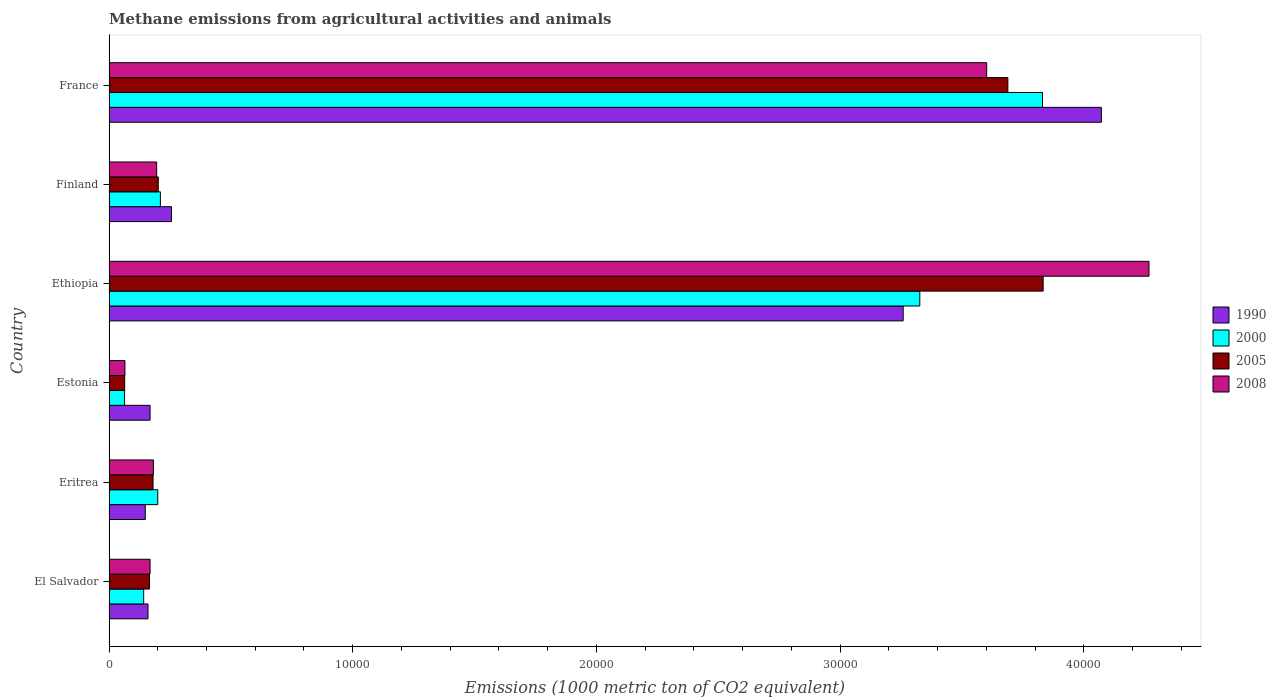How many different coloured bars are there?
Provide a short and direct response. 4. Are the number of bars per tick equal to the number of legend labels?
Make the answer very short. Yes. Are the number of bars on each tick of the Y-axis equal?
Offer a very short reply. Yes. What is the label of the 3rd group of bars from the top?
Offer a very short reply. Ethiopia. In how many cases, is the number of bars for a given country not equal to the number of legend labels?
Offer a terse response. 0. What is the amount of methane emitted in 2005 in France?
Your answer should be very brief. 3.69e+04. Across all countries, what is the maximum amount of methane emitted in 1990?
Make the answer very short. 4.07e+04. Across all countries, what is the minimum amount of methane emitted in 2005?
Your answer should be very brief. 642.9. In which country was the amount of methane emitted in 2005 maximum?
Your answer should be very brief. Ethiopia. In which country was the amount of methane emitted in 2008 minimum?
Offer a terse response. Estonia. What is the total amount of methane emitted in 1990 in the graph?
Your answer should be very brief. 8.06e+04. What is the difference between the amount of methane emitted in 1990 in Estonia and that in France?
Provide a succinct answer. -3.90e+04. What is the difference between the amount of methane emitted in 2000 in France and the amount of methane emitted in 1990 in Ethiopia?
Your answer should be very brief. 5716.5. What is the average amount of methane emitted in 2000 per country?
Offer a terse response. 1.30e+04. What is the difference between the amount of methane emitted in 2005 and amount of methane emitted in 2008 in Finland?
Offer a terse response. 65.1. What is the ratio of the amount of methane emitted in 2005 in Ethiopia to that in France?
Provide a succinct answer. 1.04. Is the amount of methane emitted in 2005 in Estonia less than that in France?
Provide a succinct answer. Yes. What is the difference between the highest and the second highest amount of methane emitted in 2008?
Offer a terse response. 6659. What is the difference between the highest and the lowest amount of methane emitted in 2005?
Offer a very short reply. 3.77e+04. Is the sum of the amount of methane emitted in 2000 in Eritrea and Finland greater than the maximum amount of methane emitted in 1990 across all countries?
Make the answer very short. No. What does the 1st bar from the top in El Salvador represents?
Provide a short and direct response. 2008. Is it the case that in every country, the sum of the amount of methane emitted in 2000 and amount of methane emitted in 2005 is greater than the amount of methane emitted in 1990?
Your answer should be compact. No. Are all the bars in the graph horizontal?
Offer a very short reply. Yes. How many countries are there in the graph?
Make the answer very short. 6. Are the values on the major ticks of X-axis written in scientific E-notation?
Offer a terse response. No. Does the graph contain grids?
Give a very brief answer. No. Where does the legend appear in the graph?
Your response must be concise. Center right. How many legend labels are there?
Offer a very short reply. 4. What is the title of the graph?
Provide a short and direct response. Methane emissions from agricultural activities and animals. Does "1978" appear as one of the legend labels in the graph?
Make the answer very short. No. What is the label or title of the X-axis?
Offer a terse response. Emissions (1000 metric ton of CO2 equivalent). What is the label or title of the Y-axis?
Offer a terse response. Country. What is the Emissions (1000 metric ton of CO2 equivalent) in 1990 in El Salvador?
Your answer should be compact. 1599.5. What is the Emissions (1000 metric ton of CO2 equivalent) in 2000 in El Salvador?
Provide a short and direct response. 1421.9. What is the Emissions (1000 metric ton of CO2 equivalent) of 2005 in El Salvador?
Ensure brevity in your answer.  1662.1. What is the Emissions (1000 metric ton of CO2 equivalent) of 2008 in El Salvador?
Keep it short and to the point. 1684.6. What is the Emissions (1000 metric ton of CO2 equivalent) of 1990 in Eritrea?
Offer a very short reply. 1488.1. What is the Emissions (1000 metric ton of CO2 equivalent) in 2000 in Eritrea?
Provide a short and direct response. 2000.3. What is the Emissions (1000 metric ton of CO2 equivalent) of 2005 in Eritrea?
Make the answer very short. 1806.6. What is the Emissions (1000 metric ton of CO2 equivalent) in 2008 in Eritrea?
Offer a very short reply. 1820.8. What is the Emissions (1000 metric ton of CO2 equivalent) in 1990 in Estonia?
Give a very brief answer. 1685. What is the Emissions (1000 metric ton of CO2 equivalent) in 2000 in Estonia?
Provide a succinct answer. 637.9. What is the Emissions (1000 metric ton of CO2 equivalent) of 2005 in Estonia?
Ensure brevity in your answer.  642.9. What is the Emissions (1000 metric ton of CO2 equivalent) of 2008 in Estonia?
Offer a very short reply. 654. What is the Emissions (1000 metric ton of CO2 equivalent) in 1990 in Ethiopia?
Ensure brevity in your answer.  3.26e+04. What is the Emissions (1000 metric ton of CO2 equivalent) of 2000 in Ethiopia?
Offer a terse response. 3.33e+04. What is the Emissions (1000 metric ton of CO2 equivalent) in 2005 in Ethiopia?
Your answer should be compact. 3.83e+04. What is the Emissions (1000 metric ton of CO2 equivalent) of 2008 in Ethiopia?
Make the answer very short. 4.27e+04. What is the Emissions (1000 metric ton of CO2 equivalent) of 1990 in Finland?
Give a very brief answer. 2564. What is the Emissions (1000 metric ton of CO2 equivalent) in 2000 in Finland?
Make the answer very short. 2107.9. What is the Emissions (1000 metric ton of CO2 equivalent) in 2005 in Finland?
Your answer should be very brief. 2020.8. What is the Emissions (1000 metric ton of CO2 equivalent) in 2008 in Finland?
Offer a terse response. 1955.7. What is the Emissions (1000 metric ton of CO2 equivalent) in 1990 in France?
Keep it short and to the point. 4.07e+04. What is the Emissions (1000 metric ton of CO2 equivalent) of 2000 in France?
Offer a very short reply. 3.83e+04. What is the Emissions (1000 metric ton of CO2 equivalent) of 2005 in France?
Offer a very short reply. 3.69e+04. What is the Emissions (1000 metric ton of CO2 equivalent) of 2008 in France?
Your answer should be very brief. 3.60e+04. Across all countries, what is the maximum Emissions (1000 metric ton of CO2 equivalent) of 1990?
Offer a terse response. 4.07e+04. Across all countries, what is the maximum Emissions (1000 metric ton of CO2 equivalent) in 2000?
Your answer should be compact. 3.83e+04. Across all countries, what is the maximum Emissions (1000 metric ton of CO2 equivalent) in 2005?
Offer a very short reply. 3.83e+04. Across all countries, what is the maximum Emissions (1000 metric ton of CO2 equivalent) of 2008?
Your answer should be compact. 4.27e+04. Across all countries, what is the minimum Emissions (1000 metric ton of CO2 equivalent) in 1990?
Provide a short and direct response. 1488.1. Across all countries, what is the minimum Emissions (1000 metric ton of CO2 equivalent) in 2000?
Make the answer very short. 637.9. Across all countries, what is the minimum Emissions (1000 metric ton of CO2 equivalent) in 2005?
Keep it short and to the point. 642.9. Across all countries, what is the minimum Emissions (1000 metric ton of CO2 equivalent) in 2008?
Give a very brief answer. 654. What is the total Emissions (1000 metric ton of CO2 equivalent) in 1990 in the graph?
Give a very brief answer. 8.06e+04. What is the total Emissions (1000 metric ton of CO2 equivalent) in 2000 in the graph?
Offer a terse response. 7.77e+04. What is the total Emissions (1000 metric ton of CO2 equivalent) in 2005 in the graph?
Make the answer very short. 8.13e+04. What is the total Emissions (1000 metric ton of CO2 equivalent) in 2008 in the graph?
Offer a terse response. 8.48e+04. What is the difference between the Emissions (1000 metric ton of CO2 equivalent) of 1990 in El Salvador and that in Eritrea?
Give a very brief answer. 111.4. What is the difference between the Emissions (1000 metric ton of CO2 equivalent) in 2000 in El Salvador and that in Eritrea?
Make the answer very short. -578.4. What is the difference between the Emissions (1000 metric ton of CO2 equivalent) of 2005 in El Salvador and that in Eritrea?
Offer a very short reply. -144.5. What is the difference between the Emissions (1000 metric ton of CO2 equivalent) in 2008 in El Salvador and that in Eritrea?
Offer a very short reply. -136.2. What is the difference between the Emissions (1000 metric ton of CO2 equivalent) in 1990 in El Salvador and that in Estonia?
Provide a succinct answer. -85.5. What is the difference between the Emissions (1000 metric ton of CO2 equivalent) of 2000 in El Salvador and that in Estonia?
Make the answer very short. 784. What is the difference between the Emissions (1000 metric ton of CO2 equivalent) of 2005 in El Salvador and that in Estonia?
Provide a succinct answer. 1019.2. What is the difference between the Emissions (1000 metric ton of CO2 equivalent) in 2008 in El Salvador and that in Estonia?
Provide a succinct answer. 1030.6. What is the difference between the Emissions (1000 metric ton of CO2 equivalent) in 1990 in El Salvador and that in Ethiopia?
Give a very brief answer. -3.10e+04. What is the difference between the Emissions (1000 metric ton of CO2 equivalent) in 2000 in El Salvador and that in Ethiopia?
Offer a terse response. -3.18e+04. What is the difference between the Emissions (1000 metric ton of CO2 equivalent) in 2005 in El Salvador and that in Ethiopia?
Your answer should be very brief. -3.67e+04. What is the difference between the Emissions (1000 metric ton of CO2 equivalent) of 2008 in El Salvador and that in Ethiopia?
Your answer should be very brief. -4.10e+04. What is the difference between the Emissions (1000 metric ton of CO2 equivalent) in 1990 in El Salvador and that in Finland?
Offer a terse response. -964.5. What is the difference between the Emissions (1000 metric ton of CO2 equivalent) of 2000 in El Salvador and that in Finland?
Provide a succinct answer. -686. What is the difference between the Emissions (1000 metric ton of CO2 equivalent) of 2005 in El Salvador and that in Finland?
Offer a terse response. -358.7. What is the difference between the Emissions (1000 metric ton of CO2 equivalent) of 2008 in El Salvador and that in Finland?
Your response must be concise. -271.1. What is the difference between the Emissions (1000 metric ton of CO2 equivalent) in 1990 in El Salvador and that in France?
Make the answer very short. -3.91e+04. What is the difference between the Emissions (1000 metric ton of CO2 equivalent) in 2000 in El Salvador and that in France?
Your response must be concise. -3.69e+04. What is the difference between the Emissions (1000 metric ton of CO2 equivalent) of 2005 in El Salvador and that in France?
Ensure brevity in your answer.  -3.52e+04. What is the difference between the Emissions (1000 metric ton of CO2 equivalent) in 2008 in El Salvador and that in France?
Provide a succinct answer. -3.43e+04. What is the difference between the Emissions (1000 metric ton of CO2 equivalent) of 1990 in Eritrea and that in Estonia?
Offer a very short reply. -196.9. What is the difference between the Emissions (1000 metric ton of CO2 equivalent) of 2000 in Eritrea and that in Estonia?
Ensure brevity in your answer.  1362.4. What is the difference between the Emissions (1000 metric ton of CO2 equivalent) of 2005 in Eritrea and that in Estonia?
Make the answer very short. 1163.7. What is the difference between the Emissions (1000 metric ton of CO2 equivalent) in 2008 in Eritrea and that in Estonia?
Your answer should be very brief. 1166.8. What is the difference between the Emissions (1000 metric ton of CO2 equivalent) in 1990 in Eritrea and that in Ethiopia?
Provide a short and direct response. -3.11e+04. What is the difference between the Emissions (1000 metric ton of CO2 equivalent) in 2000 in Eritrea and that in Ethiopia?
Offer a terse response. -3.13e+04. What is the difference between the Emissions (1000 metric ton of CO2 equivalent) of 2005 in Eritrea and that in Ethiopia?
Make the answer very short. -3.65e+04. What is the difference between the Emissions (1000 metric ton of CO2 equivalent) of 2008 in Eritrea and that in Ethiopia?
Offer a terse response. -4.09e+04. What is the difference between the Emissions (1000 metric ton of CO2 equivalent) of 1990 in Eritrea and that in Finland?
Your answer should be compact. -1075.9. What is the difference between the Emissions (1000 metric ton of CO2 equivalent) in 2000 in Eritrea and that in Finland?
Provide a short and direct response. -107.6. What is the difference between the Emissions (1000 metric ton of CO2 equivalent) of 2005 in Eritrea and that in Finland?
Provide a short and direct response. -214.2. What is the difference between the Emissions (1000 metric ton of CO2 equivalent) of 2008 in Eritrea and that in Finland?
Make the answer very short. -134.9. What is the difference between the Emissions (1000 metric ton of CO2 equivalent) in 1990 in Eritrea and that in France?
Give a very brief answer. -3.92e+04. What is the difference between the Emissions (1000 metric ton of CO2 equivalent) in 2000 in Eritrea and that in France?
Provide a short and direct response. -3.63e+04. What is the difference between the Emissions (1000 metric ton of CO2 equivalent) of 2005 in Eritrea and that in France?
Provide a succinct answer. -3.51e+04. What is the difference between the Emissions (1000 metric ton of CO2 equivalent) in 2008 in Eritrea and that in France?
Offer a terse response. -3.42e+04. What is the difference between the Emissions (1000 metric ton of CO2 equivalent) in 1990 in Estonia and that in Ethiopia?
Offer a very short reply. -3.09e+04. What is the difference between the Emissions (1000 metric ton of CO2 equivalent) of 2000 in Estonia and that in Ethiopia?
Keep it short and to the point. -3.26e+04. What is the difference between the Emissions (1000 metric ton of CO2 equivalent) of 2005 in Estonia and that in Ethiopia?
Your answer should be very brief. -3.77e+04. What is the difference between the Emissions (1000 metric ton of CO2 equivalent) of 2008 in Estonia and that in Ethiopia?
Ensure brevity in your answer.  -4.20e+04. What is the difference between the Emissions (1000 metric ton of CO2 equivalent) in 1990 in Estonia and that in Finland?
Your answer should be very brief. -879. What is the difference between the Emissions (1000 metric ton of CO2 equivalent) in 2000 in Estonia and that in Finland?
Offer a very short reply. -1470. What is the difference between the Emissions (1000 metric ton of CO2 equivalent) of 2005 in Estonia and that in Finland?
Provide a short and direct response. -1377.9. What is the difference between the Emissions (1000 metric ton of CO2 equivalent) in 2008 in Estonia and that in Finland?
Offer a terse response. -1301.7. What is the difference between the Emissions (1000 metric ton of CO2 equivalent) of 1990 in Estonia and that in France?
Give a very brief answer. -3.90e+04. What is the difference between the Emissions (1000 metric ton of CO2 equivalent) in 2000 in Estonia and that in France?
Ensure brevity in your answer.  -3.77e+04. What is the difference between the Emissions (1000 metric ton of CO2 equivalent) in 2005 in Estonia and that in France?
Ensure brevity in your answer.  -3.62e+04. What is the difference between the Emissions (1000 metric ton of CO2 equivalent) in 2008 in Estonia and that in France?
Offer a very short reply. -3.54e+04. What is the difference between the Emissions (1000 metric ton of CO2 equivalent) of 1990 in Ethiopia and that in Finland?
Make the answer very short. 3.00e+04. What is the difference between the Emissions (1000 metric ton of CO2 equivalent) in 2000 in Ethiopia and that in Finland?
Your response must be concise. 3.12e+04. What is the difference between the Emissions (1000 metric ton of CO2 equivalent) of 2005 in Ethiopia and that in Finland?
Your response must be concise. 3.63e+04. What is the difference between the Emissions (1000 metric ton of CO2 equivalent) of 2008 in Ethiopia and that in Finland?
Provide a succinct answer. 4.07e+04. What is the difference between the Emissions (1000 metric ton of CO2 equivalent) in 1990 in Ethiopia and that in France?
Ensure brevity in your answer.  -8131.8. What is the difference between the Emissions (1000 metric ton of CO2 equivalent) of 2000 in Ethiopia and that in France?
Your answer should be very brief. -5034.1. What is the difference between the Emissions (1000 metric ton of CO2 equivalent) of 2005 in Ethiopia and that in France?
Your response must be concise. 1448.1. What is the difference between the Emissions (1000 metric ton of CO2 equivalent) of 2008 in Ethiopia and that in France?
Give a very brief answer. 6659. What is the difference between the Emissions (1000 metric ton of CO2 equivalent) of 1990 in Finland and that in France?
Provide a succinct answer. -3.82e+04. What is the difference between the Emissions (1000 metric ton of CO2 equivalent) of 2000 in Finland and that in France?
Ensure brevity in your answer.  -3.62e+04. What is the difference between the Emissions (1000 metric ton of CO2 equivalent) of 2005 in Finland and that in France?
Provide a short and direct response. -3.49e+04. What is the difference between the Emissions (1000 metric ton of CO2 equivalent) in 2008 in Finland and that in France?
Keep it short and to the point. -3.41e+04. What is the difference between the Emissions (1000 metric ton of CO2 equivalent) in 1990 in El Salvador and the Emissions (1000 metric ton of CO2 equivalent) in 2000 in Eritrea?
Your response must be concise. -400.8. What is the difference between the Emissions (1000 metric ton of CO2 equivalent) in 1990 in El Salvador and the Emissions (1000 metric ton of CO2 equivalent) in 2005 in Eritrea?
Provide a short and direct response. -207.1. What is the difference between the Emissions (1000 metric ton of CO2 equivalent) in 1990 in El Salvador and the Emissions (1000 metric ton of CO2 equivalent) in 2008 in Eritrea?
Provide a short and direct response. -221.3. What is the difference between the Emissions (1000 metric ton of CO2 equivalent) in 2000 in El Salvador and the Emissions (1000 metric ton of CO2 equivalent) in 2005 in Eritrea?
Your answer should be compact. -384.7. What is the difference between the Emissions (1000 metric ton of CO2 equivalent) in 2000 in El Salvador and the Emissions (1000 metric ton of CO2 equivalent) in 2008 in Eritrea?
Make the answer very short. -398.9. What is the difference between the Emissions (1000 metric ton of CO2 equivalent) of 2005 in El Salvador and the Emissions (1000 metric ton of CO2 equivalent) of 2008 in Eritrea?
Your response must be concise. -158.7. What is the difference between the Emissions (1000 metric ton of CO2 equivalent) in 1990 in El Salvador and the Emissions (1000 metric ton of CO2 equivalent) in 2000 in Estonia?
Keep it short and to the point. 961.6. What is the difference between the Emissions (1000 metric ton of CO2 equivalent) in 1990 in El Salvador and the Emissions (1000 metric ton of CO2 equivalent) in 2005 in Estonia?
Offer a terse response. 956.6. What is the difference between the Emissions (1000 metric ton of CO2 equivalent) of 1990 in El Salvador and the Emissions (1000 metric ton of CO2 equivalent) of 2008 in Estonia?
Make the answer very short. 945.5. What is the difference between the Emissions (1000 metric ton of CO2 equivalent) in 2000 in El Salvador and the Emissions (1000 metric ton of CO2 equivalent) in 2005 in Estonia?
Your response must be concise. 779. What is the difference between the Emissions (1000 metric ton of CO2 equivalent) of 2000 in El Salvador and the Emissions (1000 metric ton of CO2 equivalent) of 2008 in Estonia?
Your response must be concise. 767.9. What is the difference between the Emissions (1000 metric ton of CO2 equivalent) of 2005 in El Salvador and the Emissions (1000 metric ton of CO2 equivalent) of 2008 in Estonia?
Offer a terse response. 1008.1. What is the difference between the Emissions (1000 metric ton of CO2 equivalent) in 1990 in El Salvador and the Emissions (1000 metric ton of CO2 equivalent) in 2000 in Ethiopia?
Offer a very short reply. -3.17e+04. What is the difference between the Emissions (1000 metric ton of CO2 equivalent) in 1990 in El Salvador and the Emissions (1000 metric ton of CO2 equivalent) in 2005 in Ethiopia?
Provide a short and direct response. -3.67e+04. What is the difference between the Emissions (1000 metric ton of CO2 equivalent) in 1990 in El Salvador and the Emissions (1000 metric ton of CO2 equivalent) in 2008 in Ethiopia?
Keep it short and to the point. -4.11e+04. What is the difference between the Emissions (1000 metric ton of CO2 equivalent) of 2000 in El Salvador and the Emissions (1000 metric ton of CO2 equivalent) of 2005 in Ethiopia?
Your answer should be compact. -3.69e+04. What is the difference between the Emissions (1000 metric ton of CO2 equivalent) in 2000 in El Salvador and the Emissions (1000 metric ton of CO2 equivalent) in 2008 in Ethiopia?
Your answer should be very brief. -4.13e+04. What is the difference between the Emissions (1000 metric ton of CO2 equivalent) in 2005 in El Salvador and the Emissions (1000 metric ton of CO2 equivalent) in 2008 in Ethiopia?
Keep it short and to the point. -4.10e+04. What is the difference between the Emissions (1000 metric ton of CO2 equivalent) of 1990 in El Salvador and the Emissions (1000 metric ton of CO2 equivalent) of 2000 in Finland?
Offer a very short reply. -508.4. What is the difference between the Emissions (1000 metric ton of CO2 equivalent) in 1990 in El Salvador and the Emissions (1000 metric ton of CO2 equivalent) in 2005 in Finland?
Offer a terse response. -421.3. What is the difference between the Emissions (1000 metric ton of CO2 equivalent) of 1990 in El Salvador and the Emissions (1000 metric ton of CO2 equivalent) of 2008 in Finland?
Keep it short and to the point. -356.2. What is the difference between the Emissions (1000 metric ton of CO2 equivalent) of 2000 in El Salvador and the Emissions (1000 metric ton of CO2 equivalent) of 2005 in Finland?
Your answer should be very brief. -598.9. What is the difference between the Emissions (1000 metric ton of CO2 equivalent) of 2000 in El Salvador and the Emissions (1000 metric ton of CO2 equivalent) of 2008 in Finland?
Ensure brevity in your answer.  -533.8. What is the difference between the Emissions (1000 metric ton of CO2 equivalent) of 2005 in El Salvador and the Emissions (1000 metric ton of CO2 equivalent) of 2008 in Finland?
Make the answer very short. -293.6. What is the difference between the Emissions (1000 metric ton of CO2 equivalent) in 1990 in El Salvador and the Emissions (1000 metric ton of CO2 equivalent) in 2000 in France?
Provide a succinct answer. -3.67e+04. What is the difference between the Emissions (1000 metric ton of CO2 equivalent) in 1990 in El Salvador and the Emissions (1000 metric ton of CO2 equivalent) in 2005 in France?
Ensure brevity in your answer.  -3.53e+04. What is the difference between the Emissions (1000 metric ton of CO2 equivalent) of 1990 in El Salvador and the Emissions (1000 metric ton of CO2 equivalent) of 2008 in France?
Provide a succinct answer. -3.44e+04. What is the difference between the Emissions (1000 metric ton of CO2 equivalent) in 2000 in El Salvador and the Emissions (1000 metric ton of CO2 equivalent) in 2005 in France?
Your response must be concise. -3.55e+04. What is the difference between the Emissions (1000 metric ton of CO2 equivalent) of 2000 in El Salvador and the Emissions (1000 metric ton of CO2 equivalent) of 2008 in France?
Give a very brief answer. -3.46e+04. What is the difference between the Emissions (1000 metric ton of CO2 equivalent) of 2005 in El Salvador and the Emissions (1000 metric ton of CO2 equivalent) of 2008 in France?
Give a very brief answer. -3.44e+04. What is the difference between the Emissions (1000 metric ton of CO2 equivalent) in 1990 in Eritrea and the Emissions (1000 metric ton of CO2 equivalent) in 2000 in Estonia?
Your answer should be compact. 850.2. What is the difference between the Emissions (1000 metric ton of CO2 equivalent) of 1990 in Eritrea and the Emissions (1000 metric ton of CO2 equivalent) of 2005 in Estonia?
Give a very brief answer. 845.2. What is the difference between the Emissions (1000 metric ton of CO2 equivalent) in 1990 in Eritrea and the Emissions (1000 metric ton of CO2 equivalent) in 2008 in Estonia?
Give a very brief answer. 834.1. What is the difference between the Emissions (1000 metric ton of CO2 equivalent) in 2000 in Eritrea and the Emissions (1000 metric ton of CO2 equivalent) in 2005 in Estonia?
Offer a very short reply. 1357.4. What is the difference between the Emissions (1000 metric ton of CO2 equivalent) of 2000 in Eritrea and the Emissions (1000 metric ton of CO2 equivalent) of 2008 in Estonia?
Provide a short and direct response. 1346.3. What is the difference between the Emissions (1000 metric ton of CO2 equivalent) of 2005 in Eritrea and the Emissions (1000 metric ton of CO2 equivalent) of 2008 in Estonia?
Your answer should be very brief. 1152.6. What is the difference between the Emissions (1000 metric ton of CO2 equivalent) of 1990 in Eritrea and the Emissions (1000 metric ton of CO2 equivalent) of 2000 in Ethiopia?
Offer a terse response. -3.18e+04. What is the difference between the Emissions (1000 metric ton of CO2 equivalent) in 1990 in Eritrea and the Emissions (1000 metric ton of CO2 equivalent) in 2005 in Ethiopia?
Ensure brevity in your answer.  -3.68e+04. What is the difference between the Emissions (1000 metric ton of CO2 equivalent) of 1990 in Eritrea and the Emissions (1000 metric ton of CO2 equivalent) of 2008 in Ethiopia?
Offer a very short reply. -4.12e+04. What is the difference between the Emissions (1000 metric ton of CO2 equivalent) of 2000 in Eritrea and the Emissions (1000 metric ton of CO2 equivalent) of 2005 in Ethiopia?
Offer a very short reply. -3.63e+04. What is the difference between the Emissions (1000 metric ton of CO2 equivalent) of 2000 in Eritrea and the Emissions (1000 metric ton of CO2 equivalent) of 2008 in Ethiopia?
Provide a succinct answer. -4.07e+04. What is the difference between the Emissions (1000 metric ton of CO2 equivalent) in 2005 in Eritrea and the Emissions (1000 metric ton of CO2 equivalent) in 2008 in Ethiopia?
Give a very brief answer. -4.09e+04. What is the difference between the Emissions (1000 metric ton of CO2 equivalent) of 1990 in Eritrea and the Emissions (1000 metric ton of CO2 equivalent) of 2000 in Finland?
Your answer should be compact. -619.8. What is the difference between the Emissions (1000 metric ton of CO2 equivalent) of 1990 in Eritrea and the Emissions (1000 metric ton of CO2 equivalent) of 2005 in Finland?
Your response must be concise. -532.7. What is the difference between the Emissions (1000 metric ton of CO2 equivalent) in 1990 in Eritrea and the Emissions (1000 metric ton of CO2 equivalent) in 2008 in Finland?
Keep it short and to the point. -467.6. What is the difference between the Emissions (1000 metric ton of CO2 equivalent) of 2000 in Eritrea and the Emissions (1000 metric ton of CO2 equivalent) of 2005 in Finland?
Make the answer very short. -20.5. What is the difference between the Emissions (1000 metric ton of CO2 equivalent) of 2000 in Eritrea and the Emissions (1000 metric ton of CO2 equivalent) of 2008 in Finland?
Ensure brevity in your answer.  44.6. What is the difference between the Emissions (1000 metric ton of CO2 equivalent) in 2005 in Eritrea and the Emissions (1000 metric ton of CO2 equivalent) in 2008 in Finland?
Provide a succinct answer. -149.1. What is the difference between the Emissions (1000 metric ton of CO2 equivalent) of 1990 in Eritrea and the Emissions (1000 metric ton of CO2 equivalent) of 2000 in France?
Provide a succinct answer. -3.68e+04. What is the difference between the Emissions (1000 metric ton of CO2 equivalent) of 1990 in Eritrea and the Emissions (1000 metric ton of CO2 equivalent) of 2005 in France?
Your answer should be compact. -3.54e+04. What is the difference between the Emissions (1000 metric ton of CO2 equivalent) in 1990 in Eritrea and the Emissions (1000 metric ton of CO2 equivalent) in 2008 in France?
Your answer should be very brief. -3.45e+04. What is the difference between the Emissions (1000 metric ton of CO2 equivalent) of 2000 in Eritrea and the Emissions (1000 metric ton of CO2 equivalent) of 2005 in France?
Provide a short and direct response. -3.49e+04. What is the difference between the Emissions (1000 metric ton of CO2 equivalent) of 2000 in Eritrea and the Emissions (1000 metric ton of CO2 equivalent) of 2008 in France?
Your answer should be very brief. -3.40e+04. What is the difference between the Emissions (1000 metric ton of CO2 equivalent) in 2005 in Eritrea and the Emissions (1000 metric ton of CO2 equivalent) in 2008 in France?
Make the answer very short. -3.42e+04. What is the difference between the Emissions (1000 metric ton of CO2 equivalent) of 1990 in Estonia and the Emissions (1000 metric ton of CO2 equivalent) of 2000 in Ethiopia?
Make the answer very short. -3.16e+04. What is the difference between the Emissions (1000 metric ton of CO2 equivalent) of 1990 in Estonia and the Emissions (1000 metric ton of CO2 equivalent) of 2005 in Ethiopia?
Keep it short and to the point. -3.66e+04. What is the difference between the Emissions (1000 metric ton of CO2 equivalent) of 1990 in Estonia and the Emissions (1000 metric ton of CO2 equivalent) of 2008 in Ethiopia?
Provide a succinct answer. -4.10e+04. What is the difference between the Emissions (1000 metric ton of CO2 equivalent) in 2000 in Estonia and the Emissions (1000 metric ton of CO2 equivalent) in 2005 in Ethiopia?
Provide a short and direct response. -3.77e+04. What is the difference between the Emissions (1000 metric ton of CO2 equivalent) of 2000 in Estonia and the Emissions (1000 metric ton of CO2 equivalent) of 2008 in Ethiopia?
Offer a very short reply. -4.20e+04. What is the difference between the Emissions (1000 metric ton of CO2 equivalent) in 2005 in Estonia and the Emissions (1000 metric ton of CO2 equivalent) in 2008 in Ethiopia?
Provide a short and direct response. -4.20e+04. What is the difference between the Emissions (1000 metric ton of CO2 equivalent) of 1990 in Estonia and the Emissions (1000 metric ton of CO2 equivalent) of 2000 in Finland?
Provide a succinct answer. -422.9. What is the difference between the Emissions (1000 metric ton of CO2 equivalent) of 1990 in Estonia and the Emissions (1000 metric ton of CO2 equivalent) of 2005 in Finland?
Offer a terse response. -335.8. What is the difference between the Emissions (1000 metric ton of CO2 equivalent) of 1990 in Estonia and the Emissions (1000 metric ton of CO2 equivalent) of 2008 in Finland?
Your response must be concise. -270.7. What is the difference between the Emissions (1000 metric ton of CO2 equivalent) of 2000 in Estonia and the Emissions (1000 metric ton of CO2 equivalent) of 2005 in Finland?
Your answer should be very brief. -1382.9. What is the difference between the Emissions (1000 metric ton of CO2 equivalent) of 2000 in Estonia and the Emissions (1000 metric ton of CO2 equivalent) of 2008 in Finland?
Provide a short and direct response. -1317.8. What is the difference between the Emissions (1000 metric ton of CO2 equivalent) in 2005 in Estonia and the Emissions (1000 metric ton of CO2 equivalent) in 2008 in Finland?
Your answer should be compact. -1312.8. What is the difference between the Emissions (1000 metric ton of CO2 equivalent) in 1990 in Estonia and the Emissions (1000 metric ton of CO2 equivalent) in 2000 in France?
Your answer should be compact. -3.66e+04. What is the difference between the Emissions (1000 metric ton of CO2 equivalent) in 1990 in Estonia and the Emissions (1000 metric ton of CO2 equivalent) in 2005 in France?
Keep it short and to the point. -3.52e+04. What is the difference between the Emissions (1000 metric ton of CO2 equivalent) in 1990 in Estonia and the Emissions (1000 metric ton of CO2 equivalent) in 2008 in France?
Make the answer very short. -3.43e+04. What is the difference between the Emissions (1000 metric ton of CO2 equivalent) in 2000 in Estonia and the Emissions (1000 metric ton of CO2 equivalent) in 2005 in France?
Ensure brevity in your answer.  -3.62e+04. What is the difference between the Emissions (1000 metric ton of CO2 equivalent) of 2000 in Estonia and the Emissions (1000 metric ton of CO2 equivalent) of 2008 in France?
Make the answer very short. -3.54e+04. What is the difference between the Emissions (1000 metric ton of CO2 equivalent) in 2005 in Estonia and the Emissions (1000 metric ton of CO2 equivalent) in 2008 in France?
Provide a succinct answer. -3.54e+04. What is the difference between the Emissions (1000 metric ton of CO2 equivalent) in 1990 in Ethiopia and the Emissions (1000 metric ton of CO2 equivalent) in 2000 in Finland?
Provide a succinct answer. 3.05e+04. What is the difference between the Emissions (1000 metric ton of CO2 equivalent) in 1990 in Ethiopia and the Emissions (1000 metric ton of CO2 equivalent) in 2005 in Finland?
Give a very brief answer. 3.06e+04. What is the difference between the Emissions (1000 metric ton of CO2 equivalent) of 1990 in Ethiopia and the Emissions (1000 metric ton of CO2 equivalent) of 2008 in Finland?
Your answer should be very brief. 3.06e+04. What is the difference between the Emissions (1000 metric ton of CO2 equivalent) in 2000 in Ethiopia and the Emissions (1000 metric ton of CO2 equivalent) in 2005 in Finland?
Make the answer very short. 3.12e+04. What is the difference between the Emissions (1000 metric ton of CO2 equivalent) in 2000 in Ethiopia and the Emissions (1000 metric ton of CO2 equivalent) in 2008 in Finland?
Your answer should be compact. 3.13e+04. What is the difference between the Emissions (1000 metric ton of CO2 equivalent) of 2005 in Ethiopia and the Emissions (1000 metric ton of CO2 equivalent) of 2008 in Finland?
Offer a very short reply. 3.64e+04. What is the difference between the Emissions (1000 metric ton of CO2 equivalent) of 1990 in Ethiopia and the Emissions (1000 metric ton of CO2 equivalent) of 2000 in France?
Keep it short and to the point. -5716.5. What is the difference between the Emissions (1000 metric ton of CO2 equivalent) in 1990 in Ethiopia and the Emissions (1000 metric ton of CO2 equivalent) in 2005 in France?
Provide a succinct answer. -4295.3. What is the difference between the Emissions (1000 metric ton of CO2 equivalent) of 1990 in Ethiopia and the Emissions (1000 metric ton of CO2 equivalent) of 2008 in France?
Offer a terse response. -3427.1. What is the difference between the Emissions (1000 metric ton of CO2 equivalent) of 2000 in Ethiopia and the Emissions (1000 metric ton of CO2 equivalent) of 2005 in France?
Your response must be concise. -3612.9. What is the difference between the Emissions (1000 metric ton of CO2 equivalent) of 2000 in Ethiopia and the Emissions (1000 metric ton of CO2 equivalent) of 2008 in France?
Provide a succinct answer. -2744.7. What is the difference between the Emissions (1000 metric ton of CO2 equivalent) in 2005 in Ethiopia and the Emissions (1000 metric ton of CO2 equivalent) in 2008 in France?
Offer a terse response. 2316.3. What is the difference between the Emissions (1000 metric ton of CO2 equivalent) of 1990 in Finland and the Emissions (1000 metric ton of CO2 equivalent) of 2000 in France?
Offer a very short reply. -3.57e+04. What is the difference between the Emissions (1000 metric ton of CO2 equivalent) of 1990 in Finland and the Emissions (1000 metric ton of CO2 equivalent) of 2005 in France?
Keep it short and to the point. -3.43e+04. What is the difference between the Emissions (1000 metric ton of CO2 equivalent) in 1990 in Finland and the Emissions (1000 metric ton of CO2 equivalent) in 2008 in France?
Keep it short and to the point. -3.34e+04. What is the difference between the Emissions (1000 metric ton of CO2 equivalent) of 2000 in Finland and the Emissions (1000 metric ton of CO2 equivalent) of 2005 in France?
Your response must be concise. -3.48e+04. What is the difference between the Emissions (1000 metric ton of CO2 equivalent) in 2000 in Finland and the Emissions (1000 metric ton of CO2 equivalent) in 2008 in France?
Offer a terse response. -3.39e+04. What is the difference between the Emissions (1000 metric ton of CO2 equivalent) in 2005 in Finland and the Emissions (1000 metric ton of CO2 equivalent) in 2008 in France?
Make the answer very short. -3.40e+04. What is the average Emissions (1000 metric ton of CO2 equivalent) of 1990 per country?
Your answer should be very brief. 1.34e+04. What is the average Emissions (1000 metric ton of CO2 equivalent) of 2000 per country?
Offer a very short reply. 1.30e+04. What is the average Emissions (1000 metric ton of CO2 equivalent) in 2005 per country?
Offer a very short reply. 1.36e+04. What is the average Emissions (1000 metric ton of CO2 equivalent) in 2008 per country?
Offer a terse response. 1.41e+04. What is the difference between the Emissions (1000 metric ton of CO2 equivalent) in 1990 and Emissions (1000 metric ton of CO2 equivalent) in 2000 in El Salvador?
Keep it short and to the point. 177.6. What is the difference between the Emissions (1000 metric ton of CO2 equivalent) in 1990 and Emissions (1000 metric ton of CO2 equivalent) in 2005 in El Salvador?
Ensure brevity in your answer.  -62.6. What is the difference between the Emissions (1000 metric ton of CO2 equivalent) of 1990 and Emissions (1000 metric ton of CO2 equivalent) of 2008 in El Salvador?
Give a very brief answer. -85.1. What is the difference between the Emissions (1000 metric ton of CO2 equivalent) of 2000 and Emissions (1000 metric ton of CO2 equivalent) of 2005 in El Salvador?
Ensure brevity in your answer.  -240.2. What is the difference between the Emissions (1000 metric ton of CO2 equivalent) of 2000 and Emissions (1000 metric ton of CO2 equivalent) of 2008 in El Salvador?
Your response must be concise. -262.7. What is the difference between the Emissions (1000 metric ton of CO2 equivalent) in 2005 and Emissions (1000 metric ton of CO2 equivalent) in 2008 in El Salvador?
Your response must be concise. -22.5. What is the difference between the Emissions (1000 metric ton of CO2 equivalent) of 1990 and Emissions (1000 metric ton of CO2 equivalent) of 2000 in Eritrea?
Provide a succinct answer. -512.2. What is the difference between the Emissions (1000 metric ton of CO2 equivalent) of 1990 and Emissions (1000 metric ton of CO2 equivalent) of 2005 in Eritrea?
Ensure brevity in your answer.  -318.5. What is the difference between the Emissions (1000 metric ton of CO2 equivalent) in 1990 and Emissions (1000 metric ton of CO2 equivalent) in 2008 in Eritrea?
Ensure brevity in your answer.  -332.7. What is the difference between the Emissions (1000 metric ton of CO2 equivalent) in 2000 and Emissions (1000 metric ton of CO2 equivalent) in 2005 in Eritrea?
Keep it short and to the point. 193.7. What is the difference between the Emissions (1000 metric ton of CO2 equivalent) in 2000 and Emissions (1000 metric ton of CO2 equivalent) in 2008 in Eritrea?
Your answer should be compact. 179.5. What is the difference between the Emissions (1000 metric ton of CO2 equivalent) in 1990 and Emissions (1000 metric ton of CO2 equivalent) in 2000 in Estonia?
Give a very brief answer. 1047.1. What is the difference between the Emissions (1000 metric ton of CO2 equivalent) in 1990 and Emissions (1000 metric ton of CO2 equivalent) in 2005 in Estonia?
Give a very brief answer. 1042.1. What is the difference between the Emissions (1000 metric ton of CO2 equivalent) in 1990 and Emissions (1000 metric ton of CO2 equivalent) in 2008 in Estonia?
Make the answer very short. 1031. What is the difference between the Emissions (1000 metric ton of CO2 equivalent) of 2000 and Emissions (1000 metric ton of CO2 equivalent) of 2008 in Estonia?
Provide a short and direct response. -16.1. What is the difference between the Emissions (1000 metric ton of CO2 equivalent) of 2005 and Emissions (1000 metric ton of CO2 equivalent) of 2008 in Estonia?
Provide a short and direct response. -11.1. What is the difference between the Emissions (1000 metric ton of CO2 equivalent) of 1990 and Emissions (1000 metric ton of CO2 equivalent) of 2000 in Ethiopia?
Provide a short and direct response. -682.4. What is the difference between the Emissions (1000 metric ton of CO2 equivalent) of 1990 and Emissions (1000 metric ton of CO2 equivalent) of 2005 in Ethiopia?
Provide a short and direct response. -5743.4. What is the difference between the Emissions (1000 metric ton of CO2 equivalent) in 1990 and Emissions (1000 metric ton of CO2 equivalent) in 2008 in Ethiopia?
Provide a succinct answer. -1.01e+04. What is the difference between the Emissions (1000 metric ton of CO2 equivalent) in 2000 and Emissions (1000 metric ton of CO2 equivalent) in 2005 in Ethiopia?
Give a very brief answer. -5061. What is the difference between the Emissions (1000 metric ton of CO2 equivalent) in 2000 and Emissions (1000 metric ton of CO2 equivalent) in 2008 in Ethiopia?
Give a very brief answer. -9403.7. What is the difference between the Emissions (1000 metric ton of CO2 equivalent) in 2005 and Emissions (1000 metric ton of CO2 equivalent) in 2008 in Ethiopia?
Provide a succinct answer. -4342.7. What is the difference between the Emissions (1000 metric ton of CO2 equivalent) in 1990 and Emissions (1000 metric ton of CO2 equivalent) in 2000 in Finland?
Keep it short and to the point. 456.1. What is the difference between the Emissions (1000 metric ton of CO2 equivalent) of 1990 and Emissions (1000 metric ton of CO2 equivalent) of 2005 in Finland?
Offer a terse response. 543.2. What is the difference between the Emissions (1000 metric ton of CO2 equivalent) in 1990 and Emissions (1000 metric ton of CO2 equivalent) in 2008 in Finland?
Offer a terse response. 608.3. What is the difference between the Emissions (1000 metric ton of CO2 equivalent) in 2000 and Emissions (1000 metric ton of CO2 equivalent) in 2005 in Finland?
Keep it short and to the point. 87.1. What is the difference between the Emissions (1000 metric ton of CO2 equivalent) in 2000 and Emissions (1000 metric ton of CO2 equivalent) in 2008 in Finland?
Keep it short and to the point. 152.2. What is the difference between the Emissions (1000 metric ton of CO2 equivalent) in 2005 and Emissions (1000 metric ton of CO2 equivalent) in 2008 in Finland?
Ensure brevity in your answer.  65.1. What is the difference between the Emissions (1000 metric ton of CO2 equivalent) of 1990 and Emissions (1000 metric ton of CO2 equivalent) of 2000 in France?
Make the answer very short. 2415.3. What is the difference between the Emissions (1000 metric ton of CO2 equivalent) of 1990 and Emissions (1000 metric ton of CO2 equivalent) of 2005 in France?
Give a very brief answer. 3836.5. What is the difference between the Emissions (1000 metric ton of CO2 equivalent) of 1990 and Emissions (1000 metric ton of CO2 equivalent) of 2008 in France?
Your answer should be very brief. 4704.7. What is the difference between the Emissions (1000 metric ton of CO2 equivalent) in 2000 and Emissions (1000 metric ton of CO2 equivalent) in 2005 in France?
Your answer should be compact. 1421.2. What is the difference between the Emissions (1000 metric ton of CO2 equivalent) in 2000 and Emissions (1000 metric ton of CO2 equivalent) in 2008 in France?
Keep it short and to the point. 2289.4. What is the difference between the Emissions (1000 metric ton of CO2 equivalent) in 2005 and Emissions (1000 metric ton of CO2 equivalent) in 2008 in France?
Provide a succinct answer. 868.2. What is the ratio of the Emissions (1000 metric ton of CO2 equivalent) in 1990 in El Salvador to that in Eritrea?
Offer a very short reply. 1.07. What is the ratio of the Emissions (1000 metric ton of CO2 equivalent) of 2000 in El Salvador to that in Eritrea?
Provide a succinct answer. 0.71. What is the ratio of the Emissions (1000 metric ton of CO2 equivalent) of 2008 in El Salvador to that in Eritrea?
Your response must be concise. 0.93. What is the ratio of the Emissions (1000 metric ton of CO2 equivalent) in 1990 in El Salvador to that in Estonia?
Provide a succinct answer. 0.95. What is the ratio of the Emissions (1000 metric ton of CO2 equivalent) of 2000 in El Salvador to that in Estonia?
Make the answer very short. 2.23. What is the ratio of the Emissions (1000 metric ton of CO2 equivalent) in 2005 in El Salvador to that in Estonia?
Offer a terse response. 2.59. What is the ratio of the Emissions (1000 metric ton of CO2 equivalent) of 2008 in El Salvador to that in Estonia?
Make the answer very short. 2.58. What is the ratio of the Emissions (1000 metric ton of CO2 equivalent) of 1990 in El Salvador to that in Ethiopia?
Provide a short and direct response. 0.05. What is the ratio of the Emissions (1000 metric ton of CO2 equivalent) of 2000 in El Salvador to that in Ethiopia?
Your answer should be compact. 0.04. What is the ratio of the Emissions (1000 metric ton of CO2 equivalent) of 2005 in El Salvador to that in Ethiopia?
Keep it short and to the point. 0.04. What is the ratio of the Emissions (1000 metric ton of CO2 equivalent) in 2008 in El Salvador to that in Ethiopia?
Give a very brief answer. 0.04. What is the ratio of the Emissions (1000 metric ton of CO2 equivalent) in 1990 in El Salvador to that in Finland?
Make the answer very short. 0.62. What is the ratio of the Emissions (1000 metric ton of CO2 equivalent) in 2000 in El Salvador to that in Finland?
Your answer should be compact. 0.67. What is the ratio of the Emissions (1000 metric ton of CO2 equivalent) of 2005 in El Salvador to that in Finland?
Provide a short and direct response. 0.82. What is the ratio of the Emissions (1000 metric ton of CO2 equivalent) of 2008 in El Salvador to that in Finland?
Offer a terse response. 0.86. What is the ratio of the Emissions (1000 metric ton of CO2 equivalent) of 1990 in El Salvador to that in France?
Your response must be concise. 0.04. What is the ratio of the Emissions (1000 metric ton of CO2 equivalent) in 2000 in El Salvador to that in France?
Your answer should be compact. 0.04. What is the ratio of the Emissions (1000 metric ton of CO2 equivalent) of 2005 in El Salvador to that in France?
Give a very brief answer. 0.05. What is the ratio of the Emissions (1000 metric ton of CO2 equivalent) of 2008 in El Salvador to that in France?
Your answer should be compact. 0.05. What is the ratio of the Emissions (1000 metric ton of CO2 equivalent) of 1990 in Eritrea to that in Estonia?
Ensure brevity in your answer.  0.88. What is the ratio of the Emissions (1000 metric ton of CO2 equivalent) of 2000 in Eritrea to that in Estonia?
Your answer should be very brief. 3.14. What is the ratio of the Emissions (1000 metric ton of CO2 equivalent) of 2005 in Eritrea to that in Estonia?
Give a very brief answer. 2.81. What is the ratio of the Emissions (1000 metric ton of CO2 equivalent) of 2008 in Eritrea to that in Estonia?
Ensure brevity in your answer.  2.78. What is the ratio of the Emissions (1000 metric ton of CO2 equivalent) in 1990 in Eritrea to that in Ethiopia?
Offer a terse response. 0.05. What is the ratio of the Emissions (1000 metric ton of CO2 equivalent) in 2000 in Eritrea to that in Ethiopia?
Your response must be concise. 0.06. What is the ratio of the Emissions (1000 metric ton of CO2 equivalent) of 2005 in Eritrea to that in Ethiopia?
Your answer should be very brief. 0.05. What is the ratio of the Emissions (1000 metric ton of CO2 equivalent) of 2008 in Eritrea to that in Ethiopia?
Your answer should be compact. 0.04. What is the ratio of the Emissions (1000 metric ton of CO2 equivalent) of 1990 in Eritrea to that in Finland?
Your answer should be very brief. 0.58. What is the ratio of the Emissions (1000 metric ton of CO2 equivalent) of 2000 in Eritrea to that in Finland?
Offer a very short reply. 0.95. What is the ratio of the Emissions (1000 metric ton of CO2 equivalent) of 2005 in Eritrea to that in Finland?
Provide a short and direct response. 0.89. What is the ratio of the Emissions (1000 metric ton of CO2 equivalent) of 1990 in Eritrea to that in France?
Give a very brief answer. 0.04. What is the ratio of the Emissions (1000 metric ton of CO2 equivalent) in 2000 in Eritrea to that in France?
Make the answer very short. 0.05. What is the ratio of the Emissions (1000 metric ton of CO2 equivalent) of 2005 in Eritrea to that in France?
Offer a terse response. 0.05. What is the ratio of the Emissions (1000 metric ton of CO2 equivalent) in 2008 in Eritrea to that in France?
Provide a succinct answer. 0.05. What is the ratio of the Emissions (1000 metric ton of CO2 equivalent) of 1990 in Estonia to that in Ethiopia?
Make the answer very short. 0.05. What is the ratio of the Emissions (1000 metric ton of CO2 equivalent) of 2000 in Estonia to that in Ethiopia?
Keep it short and to the point. 0.02. What is the ratio of the Emissions (1000 metric ton of CO2 equivalent) of 2005 in Estonia to that in Ethiopia?
Your answer should be very brief. 0.02. What is the ratio of the Emissions (1000 metric ton of CO2 equivalent) in 2008 in Estonia to that in Ethiopia?
Your answer should be compact. 0.02. What is the ratio of the Emissions (1000 metric ton of CO2 equivalent) in 1990 in Estonia to that in Finland?
Your answer should be compact. 0.66. What is the ratio of the Emissions (1000 metric ton of CO2 equivalent) of 2000 in Estonia to that in Finland?
Make the answer very short. 0.3. What is the ratio of the Emissions (1000 metric ton of CO2 equivalent) in 2005 in Estonia to that in Finland?
Make the answer very short. 0.32. What is the ratio of the Emissions (1000 metric ton of CO2 equivalent) of 2008 in Estonia to that in Finland?
Offer a terse response. 0.33. What is the ratio of the Emissions (1000 metric ton of CO2 equivalent) in 1990 in Estonia to that in France?
Make the answer very short. 0.04. What is the ratio of the Emissions (1000 metric ton of CO2 equivalent) in 2000 in Estonia to that in France?
Your response must be concise. 0.02. What is the ratio of the Emissions (1000 metric ton of CO2 equivalent) in 2005 in Estonia to that in France?
Keep it short and to the point. 0.02. What is the ratio of the Emissions (1000 metric ton of CO2 equivalent) of 2008 in Estonia to that in France?
Your answer should be very brief. 0.02. What is the ratio of the Emissions (1000 metric ton of CO2 equivalent) in 1990 in Ethiopia to that in Finland?
Offer a terse response. 12.71. What is the ratio of the Emissions (1000 metric ton of CO2 equivalent) in 2000 in Ethiopia to that in Finland?
Ensure brevity in your answer.  15.78. What is the ratio of the Emissions (1000 metric ton of CO2 equivalent) in 2005 in Ethiopia to that in Finland?
Your response must be concise. 18.97. What is the ratio of the Emissions (1000 metric ton of CO2 equivalent) of 2008 in Ethiopia to that in Finland?
Give a very brief answer. 21.82. What is the ratio of the Emissions (1000 metric ton of CO2 equivalent) of 1990 in Ethiopia to that in France?
Your response must be concise. 0.8. What is the ratio of the Emissions (1000 metric ton of CO2 equivalent) in 2000 in Ethiopia to that in France?
Keep it short and to the point. 0.87. What is the ratio of the Emissions (1000 metric ton of CO2 equivalent) in 2005 in Ethiopia to that in France?
Your answer should be compact. 1.04. What is the ratio of the Emissions (1000 metric ton of CO2 equivalent) in 2008 in Ethiopia to that in France?
Your answer should be very brief. 1.18. What is the ratio of the Emissions (1000 metric ton of CO2 equivalent) in 1990 in Finland to that in France?
Keep it short and to the point. 0.06. What is the ratio of the Emissions (1000 metric ton of CO2 equivalent) in 2000 in Finland to that in France?
Provide a short and direct response. 0.06. What is the ratio of the Emissions (1000 metric ton of CO2 equivalent) of 2005 in Finland to that in France?
Keep it short and to the point. 0.05. What is the ratio of the Emissions (1000 metric ton of CO2 equivalent) of 2008 in Finland to that in France?
Provide a succinct answer. 0.05. What is the difference between the highest and the second highest Emissions (1000 metric ton of CO2 equivalent) in 1990?
Your answer should be very brief. 8131.8. What is the difference between the highest and the second highest Emissions (1000 metric ton of CO2 equivalent) of 2000?
Your answer should be compact. 5034.1. What is the difference between the highest and the second highest Emissions (1000 metric ton of CO2 equivalent) of 2005?
Your answer should be compact. 1448.1. What is the difference between the highest and the second highest Emissions (1000 metric ton of CO2 equivalent) of 2008?
Provide a short and direct response. 6659. What is the difference between the highest and the lowest Emissions (1000 metric ton of CO2 equivalent) of 1990?
Ensure brevity in your answer.  3.92e+04. What is the difference between the highest and the lowest Emissions (1000 metric ton of CO2 equivalent) of 2000?
Ensure brevity in your answer.  3.77e+04. What is the difference between the highest and the lowest Emissions (1000 metric ton of CO2 equivalent) of 2005?
Your response must be concise. 3.77e+04. What is the difference between the highest and the lowest Emissions (1000 metric ton of CO2 equivalent) in 2008?
Your response must be concise. 4.20e+04. 